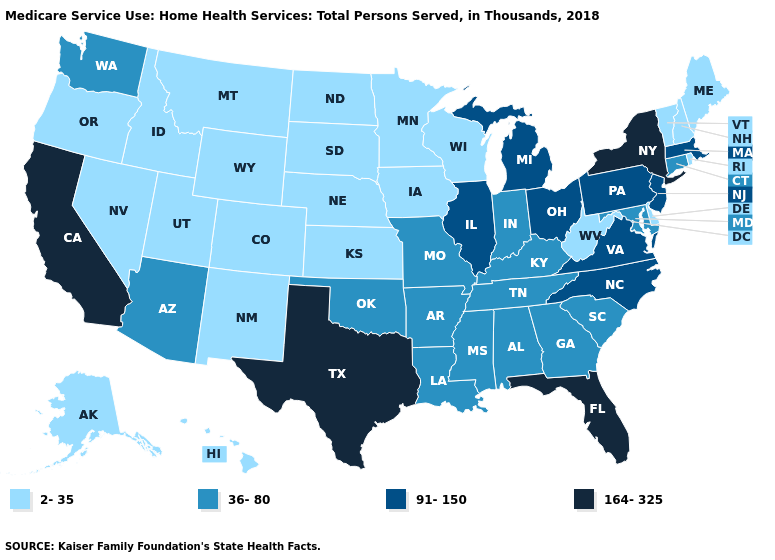Among the states that border Michigan , which have the lowest value?
Keep it brief. Wisconsin. Name the states that have a value in the range 2-35?
Write a very short answer. Alaska, Colorado, Delaware, Hawaii, Idaho, Iowa, Kansas, Maine, Minnesota, Montana, Nebraska, Nevada, New Hampshire, New Mexico, North Dakota, Oregon, Rhode Island, South Dakota, Utah, Vermont, West Virginia, Wisconsin, Wyoming. Name the states that have a value in the range 91-150?
Concise answer only. Illinois, Massachusetts, Michigan, New Jersey, North Carolina, Ohio, Pennsylvania, Virginia. Which states hav the highest value in the MidWest?
Give a very brief answer. Illinois, Michigan, Ohio. Is the legend a continuous bar?
Quick response, please. No. Name the states that have a value in the range 36-80?
Answer briefly. Alabama, Arizona, Arkansas, Connecticut, Georgia, Indiana, Kentucky, Louisiana, Maryland, Mississippi, Missouri, Oklahoma, South Carolina, Tennessee, Washington. Which states have the lowest value in the USA?
Be succinct. Alaska, Colorado, Delaware, Hawaii, Idaho, Iowa, Kansas, Maine, Minnesota, Montana, Nebraska, Nevada, New Hampshire, New Mexico, North Dakota, Oregon, Rhode Island, South Dakota, Utah, Vermont, West Virginia, Wisconsin, Wyoming. Does the first symbol in the legend represent the smallest category?
Give a very brief answer. Yes. What is the highest value in states that border Kansas?
Be succinct. 36-80. Name the states that have a value in the range 91-150?
Concise answer only. Illinois, Massachusetts, Michigan, New Jersey, North Carolina, Ohio, Pennsylvania, Virginia. Among the states that border Michigan , does Indiana have the lowest value?
Write a very short answer. No. Does Michigan have the lowest value in the MidWest?
Keep it brief. No. Which states have the highest value in the USA?
Keep it brief. California, Florida, New York, Texas. Does Iowa have a lower value than Wyoming?
Be succinct. No. Does Florida have the highest value in the USA?
Write a very short answer. Yes. 